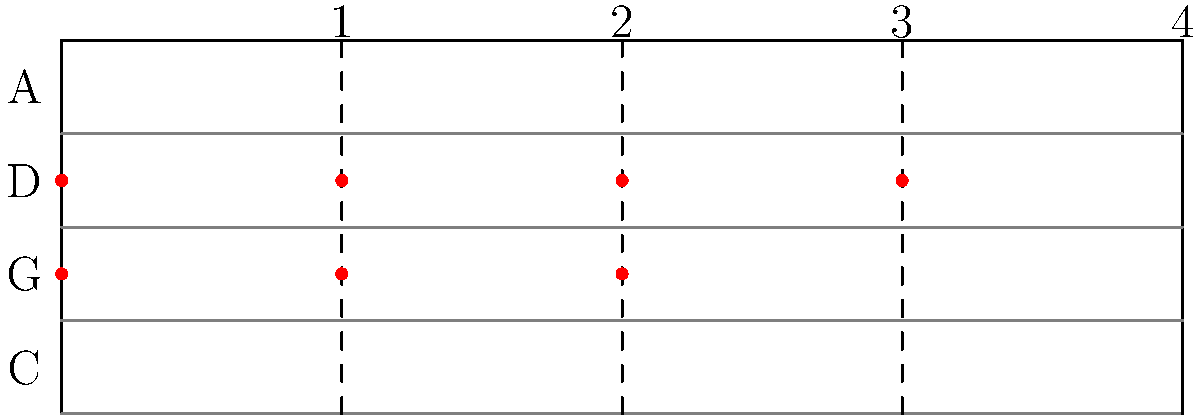Identify the scale represented by the red dots on the cello fingerboard diagram. What is the significance of this fingering pattern for cellists? To identify the scale and understand its significance, let's analyze the diagram step-by-step:

1. The diagram shows a cello fingerboard with four strings labeled C, G, D, and A from bottom to top.

2. The red dots represent finger positions for a specific scale:
   - Open G string
   - First finger on G string (A)
   - Second finger on G string (B)
   - Open D string
   - First finger on D string (E)
   - Second finger on D string (F#)
   - Third finger on D string (G)

3. These notes correspond to the G major scale: G, A, B, C, D, E, F#, G

4. The significance of this fingering pattern for cellists:
   a) It demonstrates the standard fingering for the G major scale in first position.
   b) This pattern is fundamental for cellists as G major is a common key in cello repertoire.
   c) It illustrates the use of open strings (G and D) within the scale, which is characteristic of string instrument technique.
   d) The pattern shows the whole step - whole step - half step - whole step - whole step - whole step - half step structure of a major scale.
   e) This fingering allows for smooth transitions between notes and maintains good hand position.
   f) Understanding this pattern helps cellists develop muscle memory for the G major scale, which is crucial for sight-reading and improvisation.

5. The diagram also demonstrates the importance of position playing on the cello, as all notes are played in first position, utilizing the first three fingers and open strings.
Answer: G major scale; fundamental fingering pattern in first position 